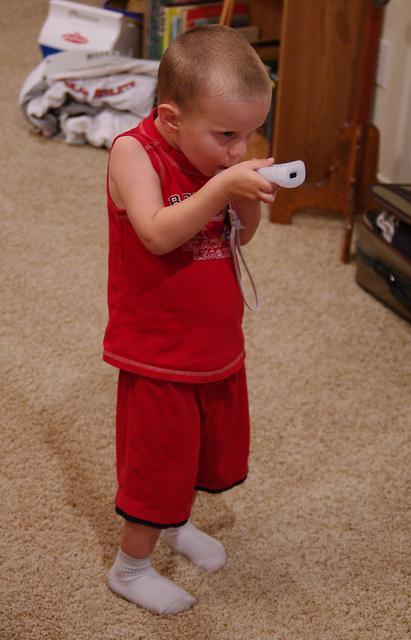How many game controllers are shown in the picture?
Give a very brief answer. 1. 